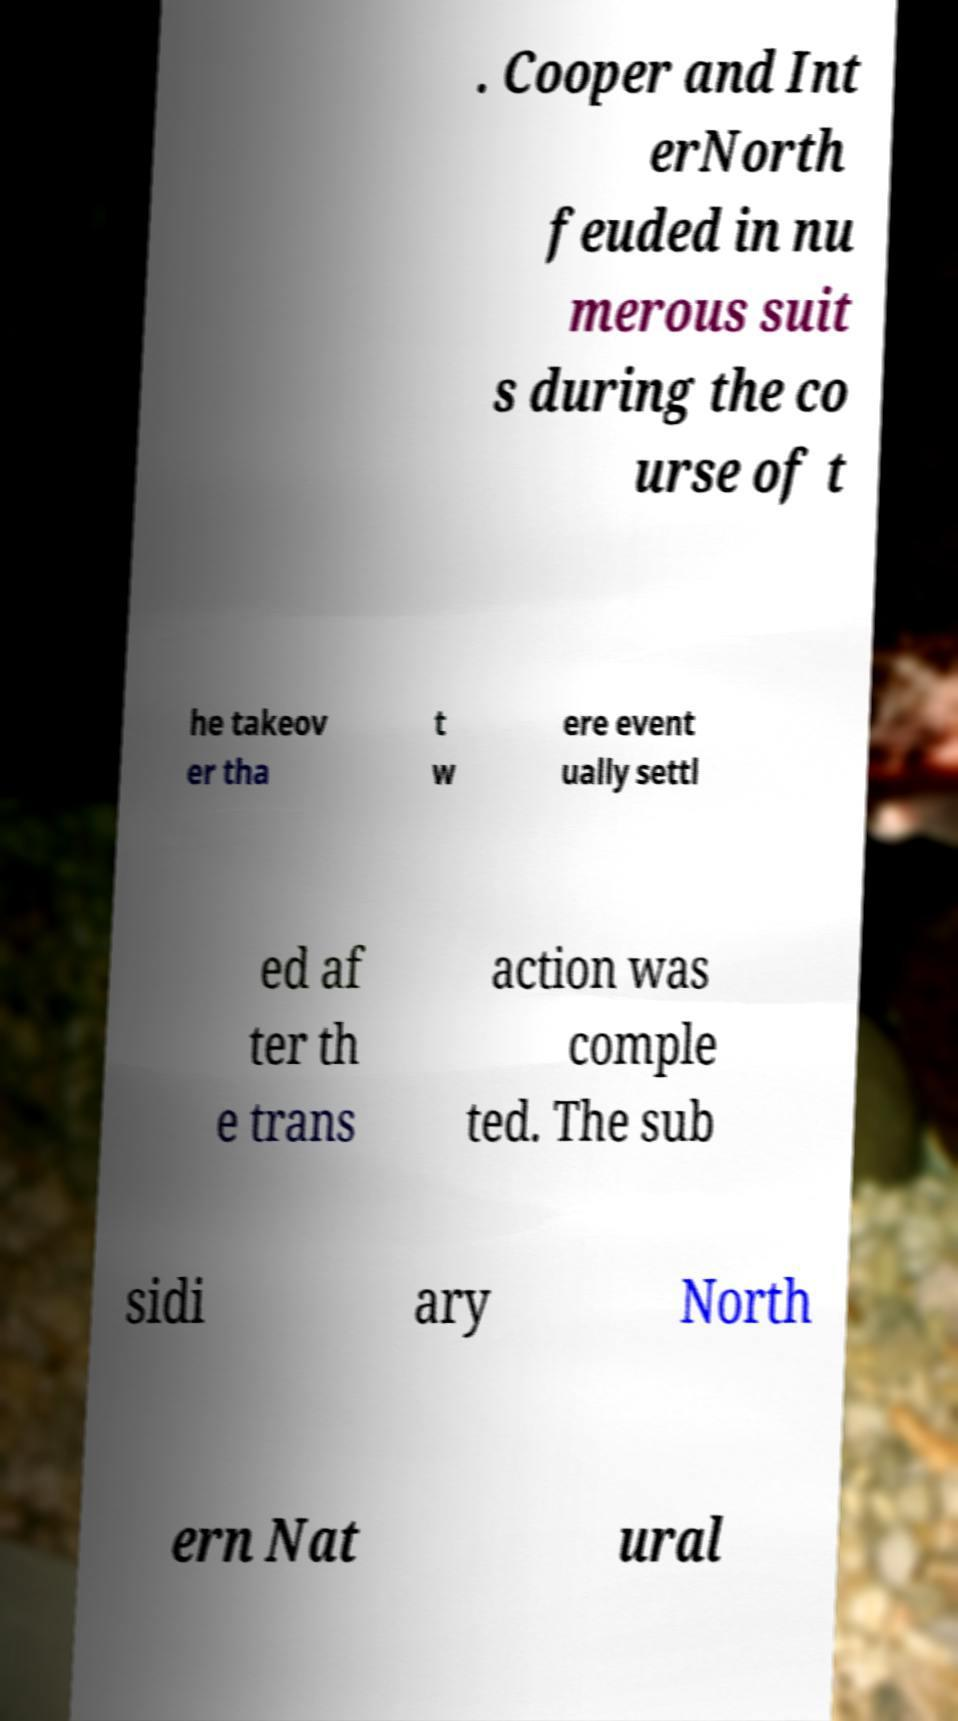Could you extract and type out the text from this image? . Cooper and Int erNorth feuded in nu merous suit s during the co urse of t he takeov er tha t w ere event ually settl ed af ter th e trans action was comple ted. The sub sidi ary North ern Nat ural 